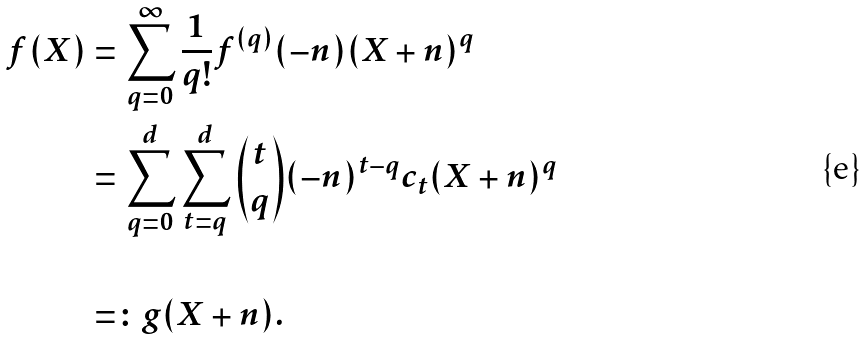<formula> <loc_0><loc_0><loc_500><loc_500>f ( X ) & = \sum _ { q = 0 } ^ { \infty } \frac { 1 } { q ! } f ^ { ( q ) } ( - n ) ( X + n ) ^ { q } \\ & = \sum _ { q = 0 } ^ { d } \sum _ { t = q } ^ { d } { t \choose q } ( - n ) ^ { t - q } c _ { t } ( X + n ) ^ { q } \\ & \\ & = \colon g ( X + n ) .</formula> 